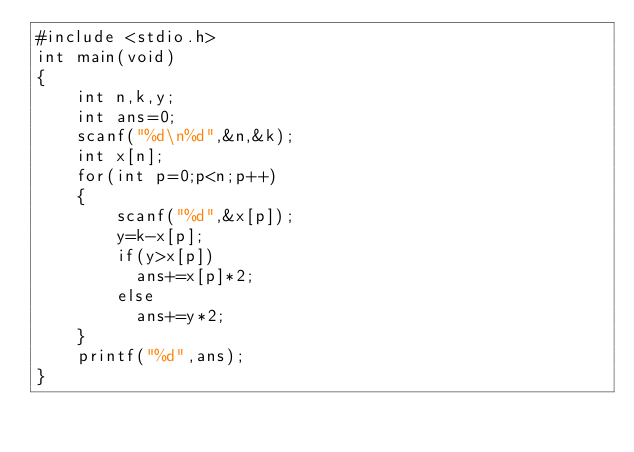Convert code to text. <code><loc_0><loc_0><loc_500><loc_500><_C_>#include <stdio.h>
int main(void)
{
    int n,k,y;
    int ans=0;
    scanf("%d\n%d",&n,&k);
    int x[n];
    for(int p=0;p<n;p++)
    {
        scanf("%d",&x[p]);
        y=k-x[p];
        if(y>x[p])
          ans+=x[p]*2;
        else
          ans+=y*2;
    }
    printf("%d",ans);
}
</code> 